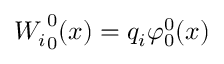<formula> <loc_0><loc_0><loc_500><loc_500>{ W _ { i } } _ { 0 } ^ { 0 } ( x ) = q _ { i } \varphi _ { 0 } ^ { 0 } ( x )</formula> 